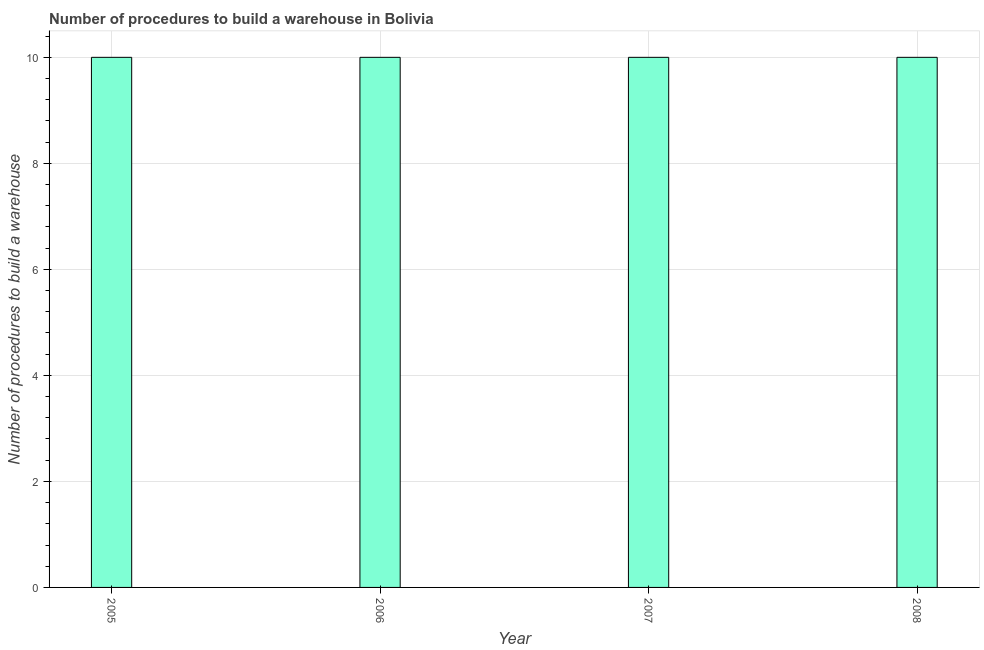Does the graph contain any zero values?
Ensure brevity in your answer.  No. Does the graph contain grids?
Make the answer very short. Yes. What is the title of the graph?
Offer a very short reply. Number of procedures to build a warehouse in Bolivia. What is the label or title of the Y-axis?
Your answer should be compact. Number of procedures to build a warehouse. Across all years, what is the minimum number of procedures to build a warehouse?
Your answer should be compact. 10. What is the sum of the number of procedures to build a warehouse?
Make the answer very short. 40. What is the difference between the number of procedures to build a warehouse in 2007 and 2008?
Your response must be concise. 0. What is the average number of procedures to build a warehouse per year?
Offer a terse response. 10. What is the median number of procedures to build a warehouse?
Your answer should be very brief. 10. Is the number of procedures to build a warehouse in 2005 less than that in 2007?
Offer a terse response. No. In how many years, is the number of procedures to build a warehouse greater than the average number of procedures to build a warehouse taken over all years?
Your answer should be compact. 0. Are all the bars in the graph horizontal?
Provide a succinct answer. No. How many years are there in the graph?
Offer a very short reply. 4. Are the values on the major ticks of Y-axis written in scientific E-notation?
Ensure brevity in your answer.  No. What is the Number of procedures to build a warehouse of 2006?
Your response must be concise. 10. What is the Number of procedures to build a warehouse of 2008?
Give a very brief answer. 10. What is the difference between the Number of procedures to build a warehouse in 2005 and 2006?
Keep it short and to the point. 0. What is the difference between the Number of procedures to build a warehouse in 2005 and 2008?
Ensure brevity in your answer.  0. What is the ratio of the Number of procedures to build a warehouse in 2005 to that in 2006?
Your response must be concise. 1. What is the ratio of the Number of procedures to build a warehouse in 2007 to that in 2008?
Your answer should be compact. 1. 